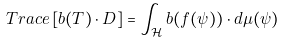Convert formula to latex. <formula><loc_0><loc_0><loc_500><loc_500>T r a c e \left [ b ( T ) \cdot D \right ] = \int _ { \mathcal { H } } b ( f ( \psi ) ) \cdot d \mu ( \psi )</formula> 